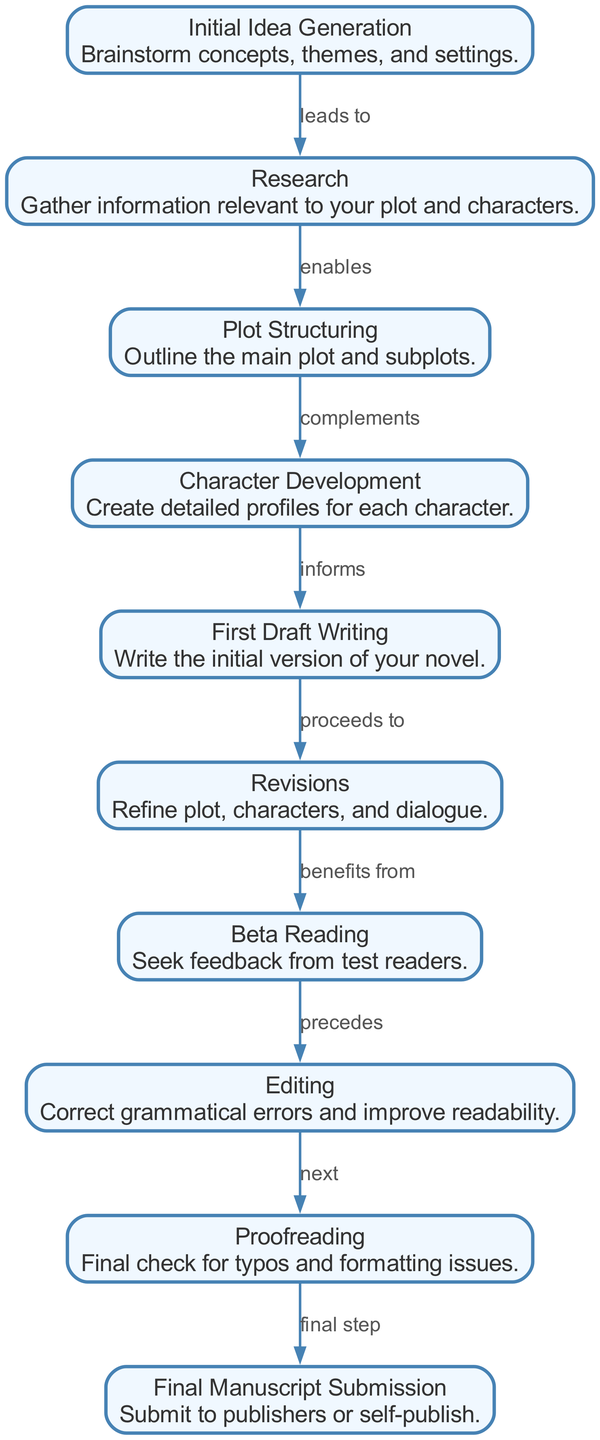What is the first node in the diagram? The first node represents "Initial Idea Generation," which is the starting point of the novel writing process. Since the nodes are outlined in the order of progression, the first one listed is the first in the diagram.
Answer: Initial Idea Generation How many edges are there in total? By counting the connections between the nodes (the edges), we find that there are 9 edges connecting the various stages of writing a novel.
Answer: 9 What node comes after First Draft Writing? The diagram indicates that "First Draft Writing" directly leads to "Revisions," suggesting it is the immediate next step after completing the first draft.
Answer: Revisions Which stages are involved in refining the manuscript? The refinement process includes "Revisions," "Beta Reading," "Editing," and "Proofreading," as each of these stages plays a role in improving the manuscript after the initial draft.
Answer: Revisions, Beta Reading, Editing, Proofreading What is the relationship between Character Development and First Draft Writing? "Character Development" directly informs "First Draft Writing," indicating that creating detailed character profiles has a significant impact on the writing of the first draft.
Answer: informs What is the final step in the writing process? The diagram clearly states that the "Final Manuscript Submission" is the last step in the process, marking the conclusion of the writing journey.
Answer: Final Manuscript Submission Which stage leads to Beta Reading? The stage that proceeds to "Beta Reading" is "Revisions," as it emphasizes the need for feedback after refining the manuscript.
Answer: Revisions What does Editing specifically focus on? "Editing" focuses on correcting grammatical errors and improving readability, as outlined explicitly in the description attached to this stage.
Answer: Correct grammatical errors and improve readability Which stage precedes Editing? According to the diagram, "Beta Reading" comes before "Editing," indicating that feedback is gathered prior to making specific edits to the manuscript.
Answer: Beta Reading 